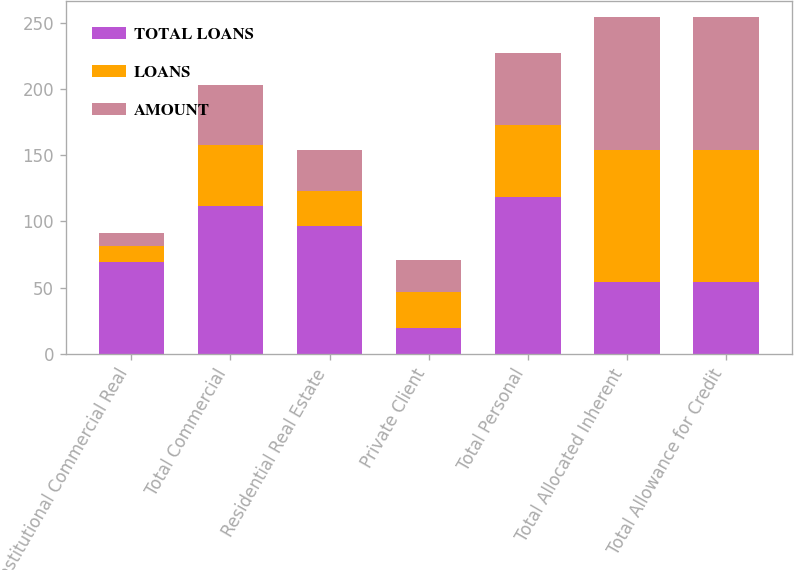<chart> <loc_0><loc_0><loc_500><loc_500><stacked_bar_chart><ecel><fcel>Institutional Commercial Real<fcel>Total Commercial<fcel>Residential Real Estate<fcel>Private Client<fcel>Total Personal<fcel>Total Allocated Inherent<fcel>Total Allowance for Credit<nl><fcel>TOTAL LOANS<fcel>69.5<fcel>111.8<fcel>96.2<fcel>19.7<fcel>118.4<fcel>54<fcel>54<nl><fcel>LOANS<fcel>12<fcel>46<fcel>27<fcel>27<fcel>54<fcel>100<fcel>100<nl><fcel>AMOUNT<fcel>10<fcel>45<fcel>31<fcel>24<fcel>55<fcel>100<fcel>100<nl></chart> 